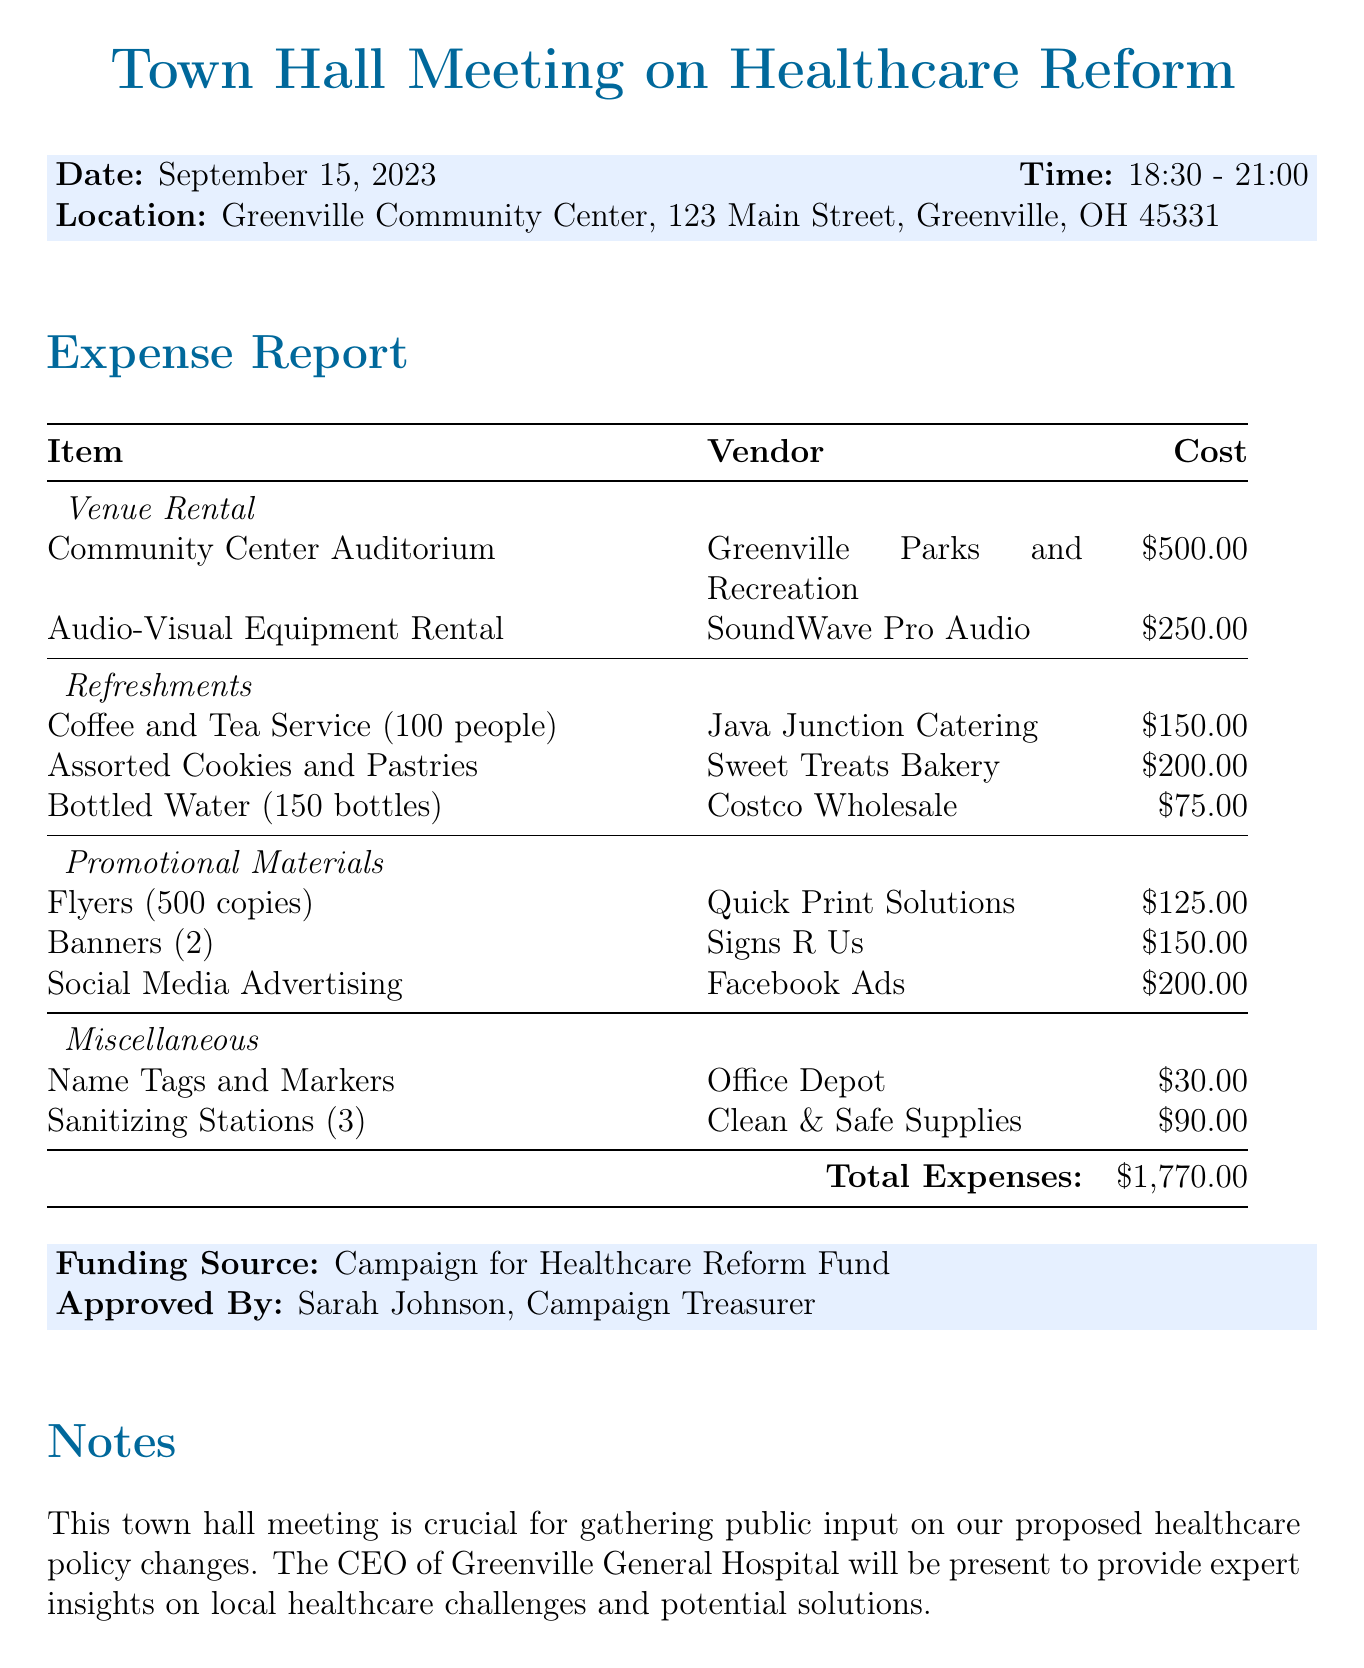What is the total expense for the event? The total expense is outlined in the document and represents the sum of all categories listed, which equals $1770.00.
Answer: $1770.00 Who is the approved by? The document explicitly states the individual responsible for approval, which is Sarah Johnson, the Campaign Treasurer.
Answer: Sarah Johnson When is the town hall meeting scheduled? The date for the town hall meeting is clearly mentioned in the document as September 15, 2023.
Answer: September 15, 2023 What venue is used for the meeting? The document identifies the location for the event as Greenville Community Center, specifying the address for reference.
Answer: Greenville Community Center What is the cost of refreshments? The total cost of refreshments can be deduced from the individual costs provided in the document, totaling $425.
Answer: $425.00 Which vendor provided the Audio-Visual Equipment Rental? The document lists the vendor associated with this service as SoundWave Pro Audio.
Answer: SoundWave Pro Audio How many people is the coffee and tea service for? The document states that the coffee and tea service is planned for 100 people.
Answer: 100 people What category does the expense for banners fall under? The expense for banners is categorized under Promotional Materials in the document.
Answer: Promotional Materials Is there a note provided in the document? Yes, the document includes a specific note emphasizing the importance of the meeting and the presence of the CEO of Greenville General Hospital.
Answer: Yes 